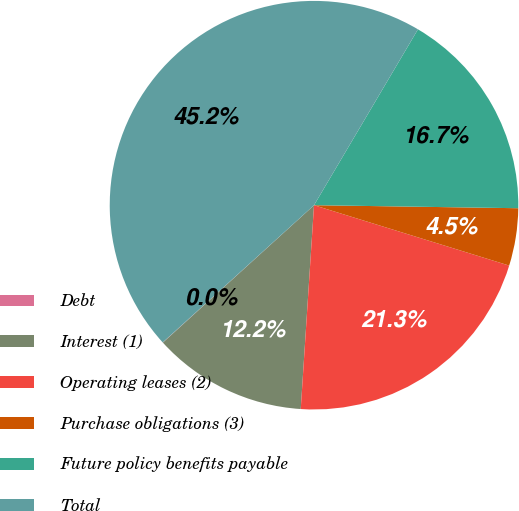<chart> <loc_0><loc_0><loc_500><loc_500><pie_chart><fcel>Debt<fcel>Interest (1)<fcel>Operating leases (2)<fcel>Purchase obligations (3)<fcel>Future policy benefits payable<fcel>Total<nl><fcel>0.02%<fcel>12.22%<fcel>21.26%<fcel>4.54%<fcel>16.74%<fcel>45.22%<nl></chart> 